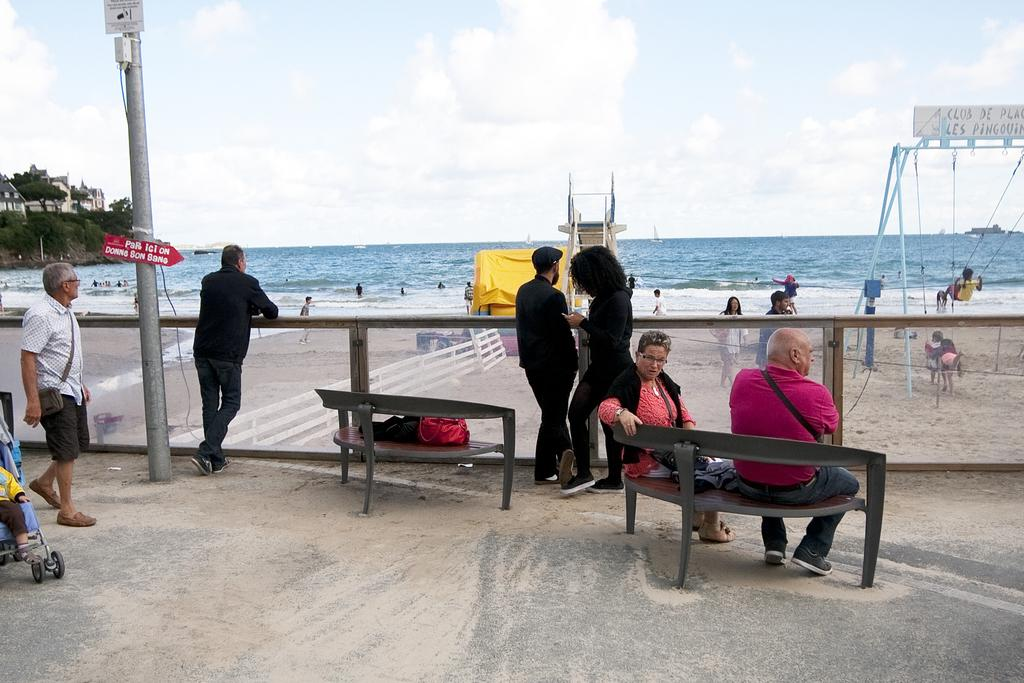What type of natural body of water is visible in the image? There is an ocean in the image. What structures can be seen near the ocean? There are houses near the ocean. What are the people in the image doing? There are people seated and standing in the image. What type of credit card is being used by the people in the image? There is no credit card visible in the image, as the focus is on the ocean, houses, and people. 